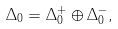Convert formula to latex. <formula><loc_0><loc_0><loc_500><loc_500>\Delta _ { 0 } = \Delta _ { 0 } ^ { + } \oplus \Delta _ { 0 } ^ { - } ,</formula> 